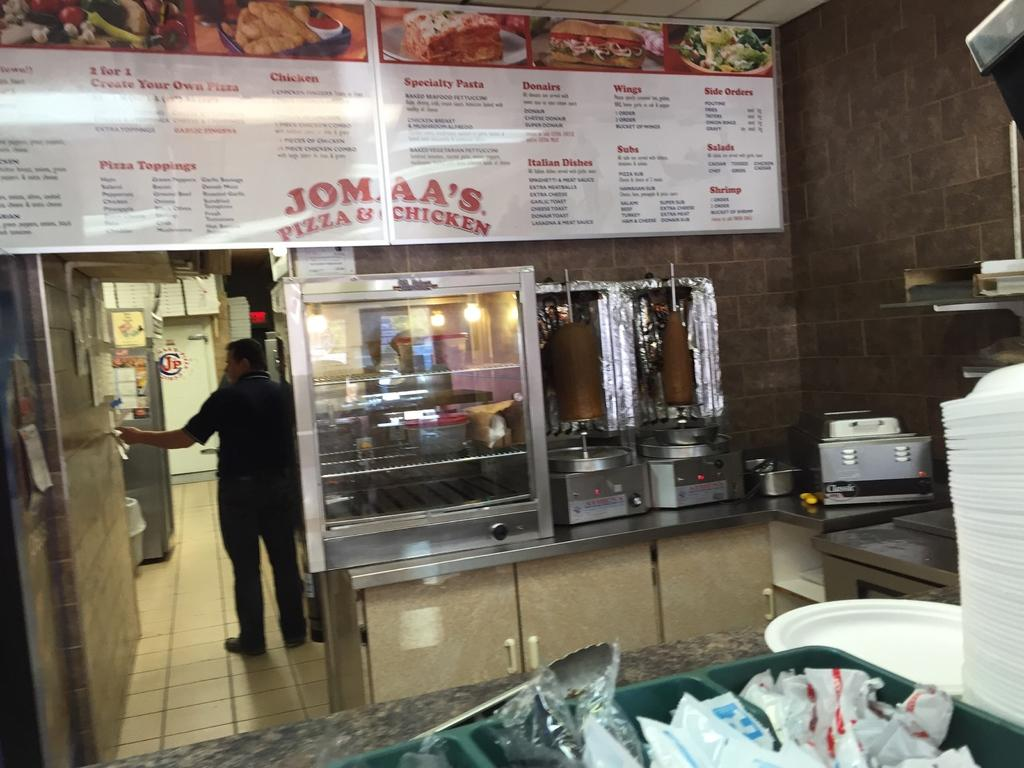<image>
Render a clear and concise summary of the photo. A man is at the rear of a Jomma's chicken shop where you can get 2 for 1 create your own pizzas. 